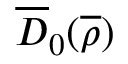Convert formula to latex. <formula><loc_0><loc_0><loc_500><loc_500>\overline { D } _ { 0 } ( \overline { \rho } )</formula> 